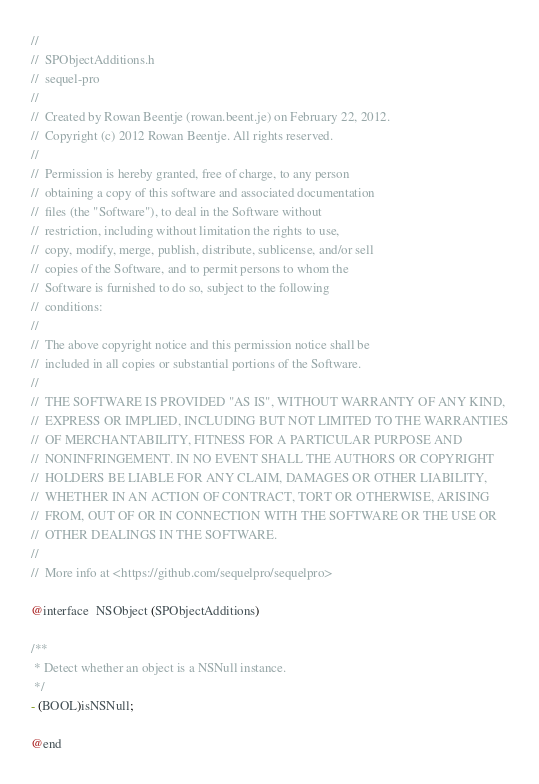Convert code to text. <code><loc_0><loc_0><loc_500><loc_500><_C_>//
//  SPObjectAdditions.h
//  sequel-pro
//
//  Created by Rowan Beentje (rowan.beent.je) on February 22, 2012.
//  Copyright (c) 2012 Rowan Beentje. All rights reserved.
//
//  Permission is hereby granted, free of charge, to any person
//  obtaining a copy of this software and associated documentation
//  files (the "Software"), to deal in the Software without
//  restriction, including without limitation the rights to use,
//  copy, modify, merge, publish, distribute, sublicense, and/or sell
//  copies of the Software, and to permit persons to whom the
//  Software is furnished to do so, subject to the following
//  conditions:
//
//  The above copyright notice and this permission notice shall be
//  included in all copies or substantial portions of the Software.
//
//  THE SOFTWARE IS PROVIDED "AS IS", WITHOUT WARRANTY OF ANY KIND,
//  EXPRESS OR IMPLIED, INCLUDING BUT NOT LIMITED TO THE WARRANTIES
//  OF MERCHANTABILITY, FITNESS FOR A PARTICULAR PURPOSE AND
//  NONINFRINGEMENT. IN NO EVENT SHALL THE AUTHORS OR COPYRIGHT
//  HOLDERS BE LIABLE FOR ANY CLAIM, DAMAGES OR OTHER LIABILITY,
//  WHETHER IN AN ACTION OF CONTRACT, TORT OR OTHERWISE, ARISING
//  FROM, OUT OF OR IN CONNECTION WITH THE SOFTWARE OR THE USE OR
//  OTHER DEALINGS IN THE SOFTWARE.
//
//  More info at <https://github.com/sequelpro/sequelpro>

@interface  NSObject (SPObjectAdditions)

/**
 * Detect whether an object is a NSNull instance.
 */
- (BOOL)isNSNull;

@end
</code> 